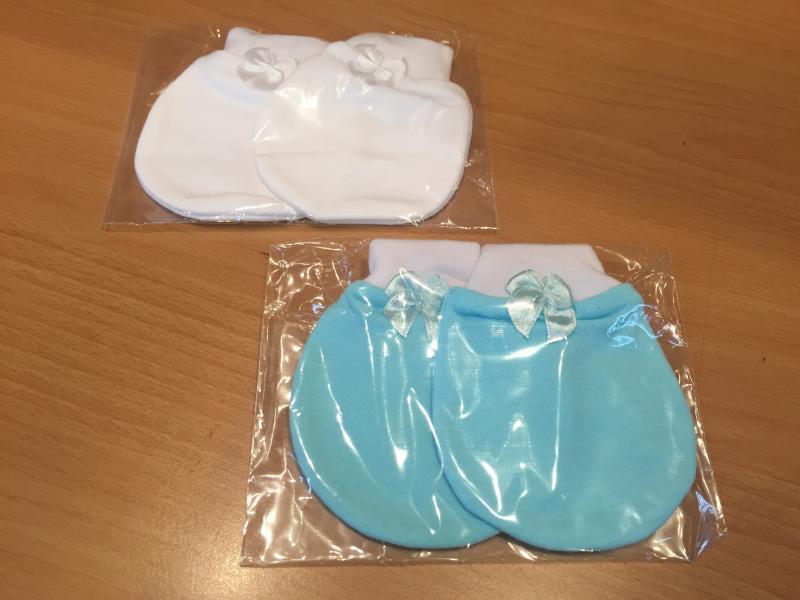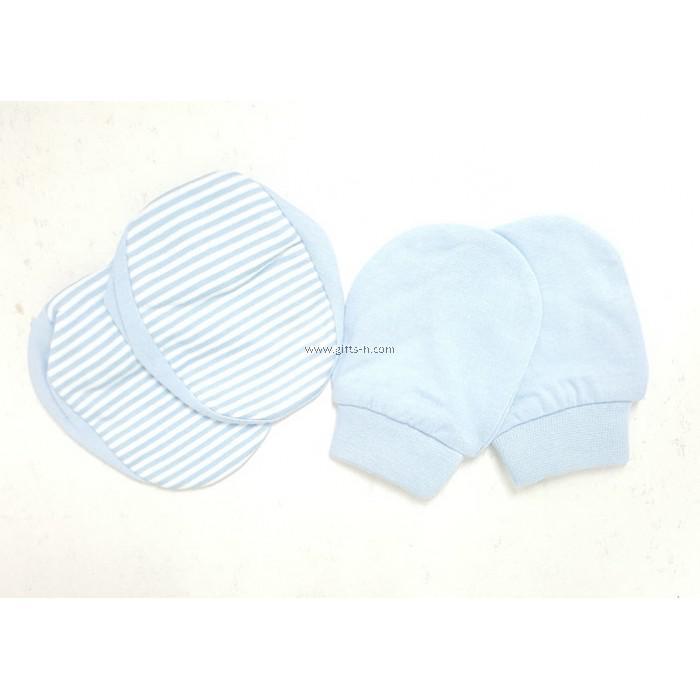The first image is the image on the left, the second image is the image on the right. Analyze the images presented: Is the assertion "The combined images include three paired items, and one paired item features black-and-white eye shapes." valid? Answer yes or no. No. The first image is the image on the left, the second image is the image on the right. For the images shown, is this caption "The left and right image contains a total of four mittens and two bootees." true? Answer yes or no. No. 